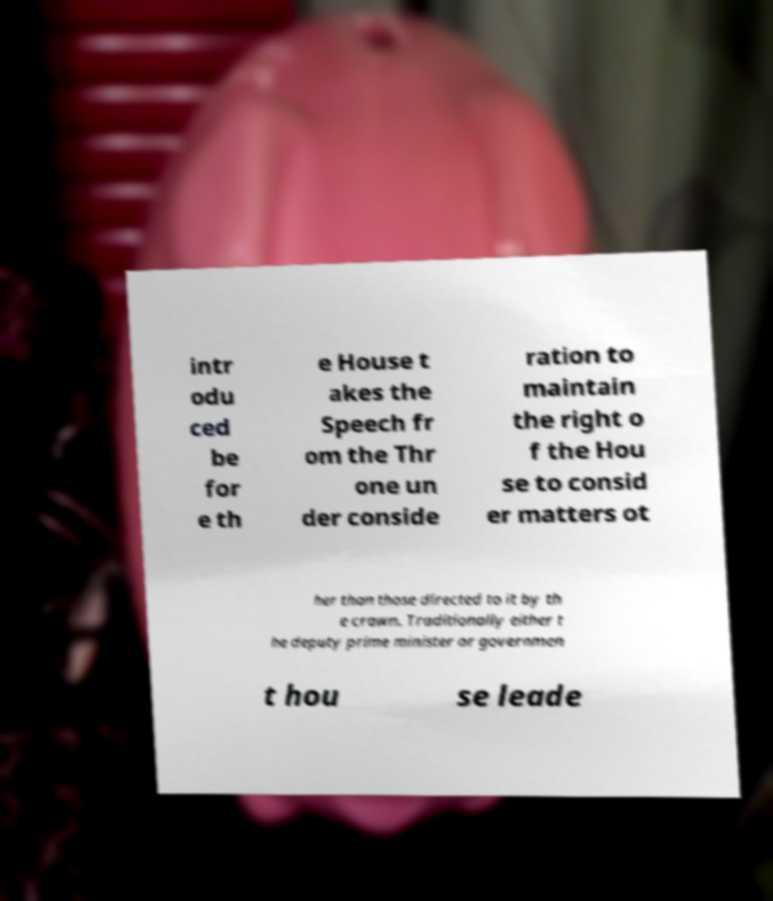There's text embedded in this image that I need extracted. Can you transcribe it verbatim? intr odu ced be for e th e House t akes the Speech fr om the Thr one un der conside ration to maintain the right o f the Hou se to consid er matters ot her than those directed to it by th e crown. Traditionally either t he deputy prime minister or governmen t hou se leade 